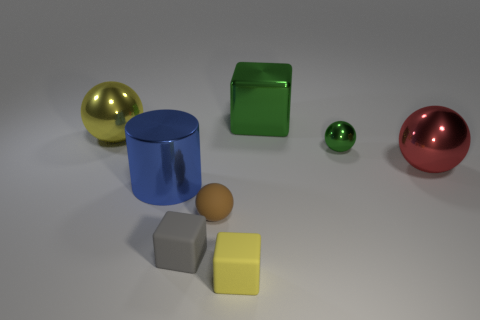There is a yellow thing in front of the small rubber sphere that is to the left of the big red shiny sphere; what is it made of?
Your response must be concise. Rubber. What size is the cube that is made of the same material as the blue object?
Your answer should be compact. Large. There is a cylinder that is left of the small object that is behind the brown matte sphere; is there a tiny metallic object left of it?
Keep it short and to the point. No. There is a thing that is behind the tiny gray block and in front of the metallic cylinder; what size is it?
Provide a short and direct response. Small. How many other things are the same shape as the red thing?
Your answer should be compact. 3. There is a thing that is both in front of the red metallic sphere and behind the tiny brown rubber sphere; what color is it?
Give a very brief answer. Blue. What is the color of the large metal block?
Make the answer very short. Green. Is the material of the red thing the same as the tiny ball that is to the left of the yellow rubber thing?
Your response must be concise. No. There is a tiny yellow object that is made of the same material as the gray object; what is its shape?
Your answer should be very brief. Cube. The metal cylinder that is the same size as the red shiny object is what color?
Your answer should be compact. Blue. 